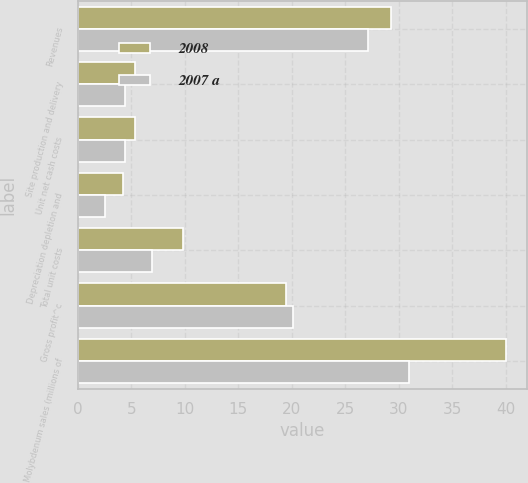Convert chart to OTSL. <chart><loc_0><loc_0><loc_500><loc_500><stacked_bar_chart><ecel><fcel>Revenues<fcel>Site production and delivery<fcel>Unit net cash costs<fcel>Depreciation depletion and<fcel>Total unit costs<fcel>Gross profit^c<fcel>Molybdenum sales (millions of<nl><fcel>2008<fcel>29.27<fcel>5.36<fcel>5.36<fcel>4.25<fcel>9.79<fcel>19.48<fcel>40<nl><fcel>2007 a<fcel>27.12<fcel>4.37<fcel>4.37<fcel>2.55<fcel>6.97<fcel>20.15<fcel>31<nl></chart> 